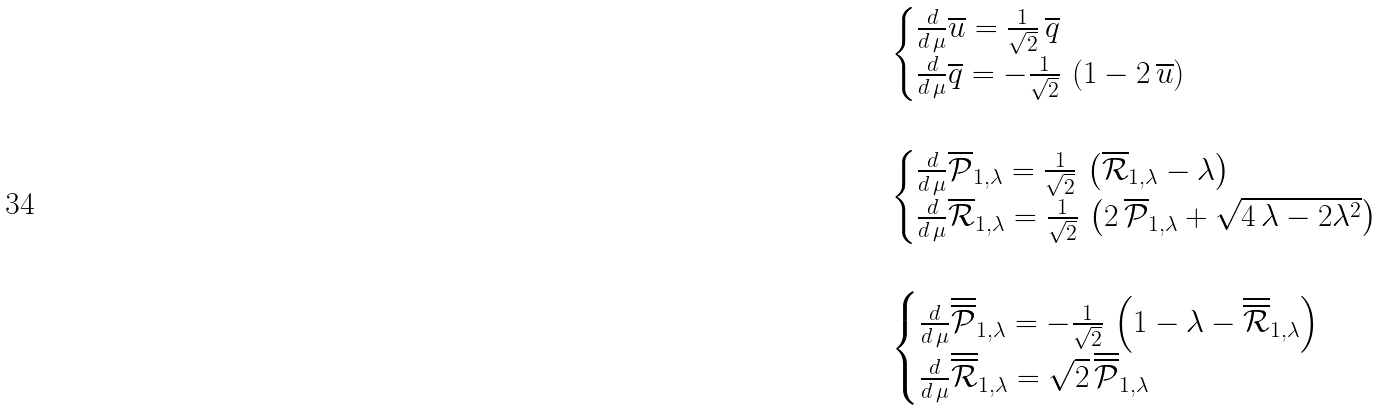Convert formula to latex. <formula><loc_0><loc_0><loc_500><loc_500>& { \begin{cases} \frac { d } { d \, \mu } \overline { u } = \frac { 1 } { \sqrt { 2 } } \, \overline { q } & \\ \frac { d } { d \, \mu } \overline { q } = - \frac { 1 } { \sqrt { 2 } } \, \left ( 1 - 2 \, \overline { u } \right ) & \end{cases} } \\ \\ & { \begin{cases} \frac { d } { d \, \mu } \overline { \mathcal { P } } _ { 1 , \lambda } = \frac { 1 } { \sqrt { 2 } } \, \left ( \overline { \mathcal { R } } _ { 1 , \lambda } - \lambda \right ) & \\ \frac { d } { d \, \mu } \overline { \mathcal { R } } _ { 1 , \lambda } = \frac { 1 } { \sqrt { 2 } } \, \left ( 2 \, \overline { \mathcal { P } } _ { 1 , \lambda } + \sqrt { 4 \, \lambda - 2 \lambda ^ { 2 } } \right ) & \end{cases} } \\ \\ & { \begin{cases} \frac { d } { d \, \mu } \overline { \overline { \mathcal { P } } } _ { 1 , \lambda } = - \frac { 1 } { \sqrt { 2 } } \, \left ( 1 - \lambda - \overline { \overline { \mathcal { R } } } _ { 1 , \lambda } \right ) & \\ \frac { d } { d \, \mu } \overline { \overline { \mathcal { R } } } _ { 1 , \lambda } = \sqrt { 2 } \, \overline { \overline { \mathcal { P } } } _ { 1 , \lambda } & \end{cases} }</formula> 